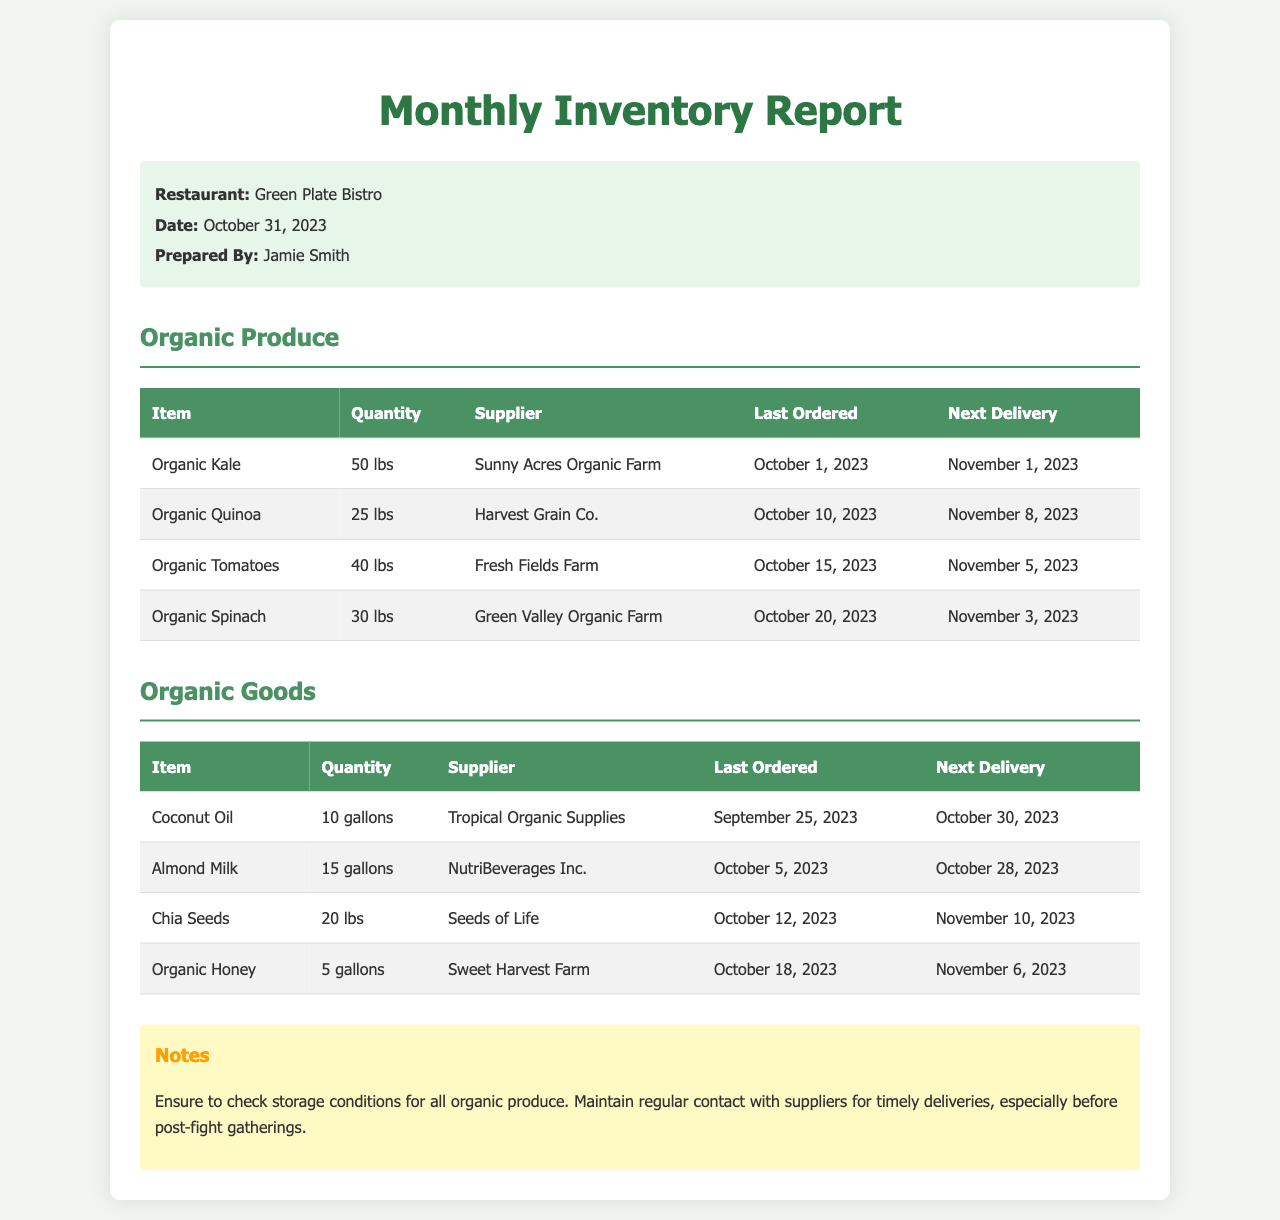What is the name of the restaurant? The restaurant name is displayed prominently at the top of the report.
Answer: Green Plate Bistro Who prepared the report? The name of the person who prepared the report is mentioned in the meta-info section.
Answer: Jamie Smith How much Organic Kale is in stock? The quantity of Organic Kale is provided in the organic produce section of the table.
Answer: 50 lbs What is the next delivery date for Organic Quinoa? The next delivery date for Organic Quinoa is listed in the corresponding table row.
Answer: November 8, 2023 Which supplier provides Organic Spinach? The supplier for Organic Spinach can be found in the organic produce table.
Answer: Green Valley Organic Farm How many gallons of Coconut Oil are in stock? The stock quantity for Coconut Oil is specified in the organic goods section of the report.
Answer: 10 gallons What are the last ordered dates for Chia Seeds? The last ordered dates for Chia Seeds can be found in the organic goods table under the appropriate column.
Answer: October 12, 2023 What is included in the notes section? The notes section provides guidance regarding handling stock and supplier interactions.
Answer: Ensure to check storage conditions for all organic produce What should be maintained with suppliers according to the notes? The notes emphasize the importance of supplier interaction timings.
Answer: Regular contact for timely deliveries 